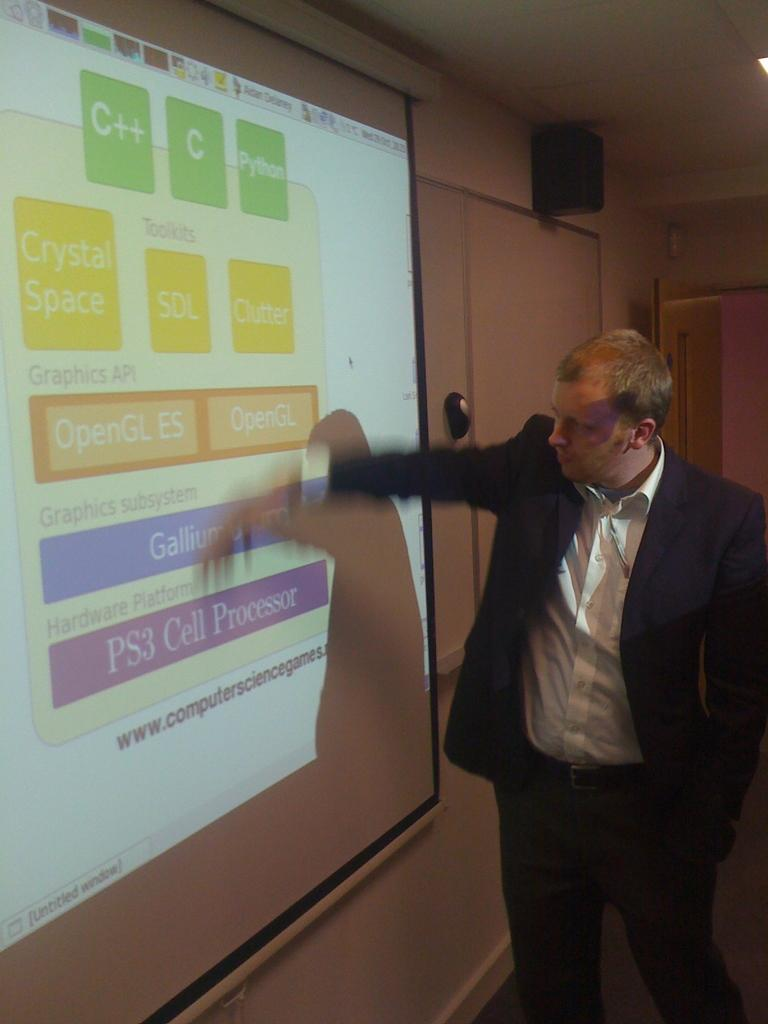<image>
Create a compact narrative representing the image presented. A man in a suit is presenting a slide about computer science. 